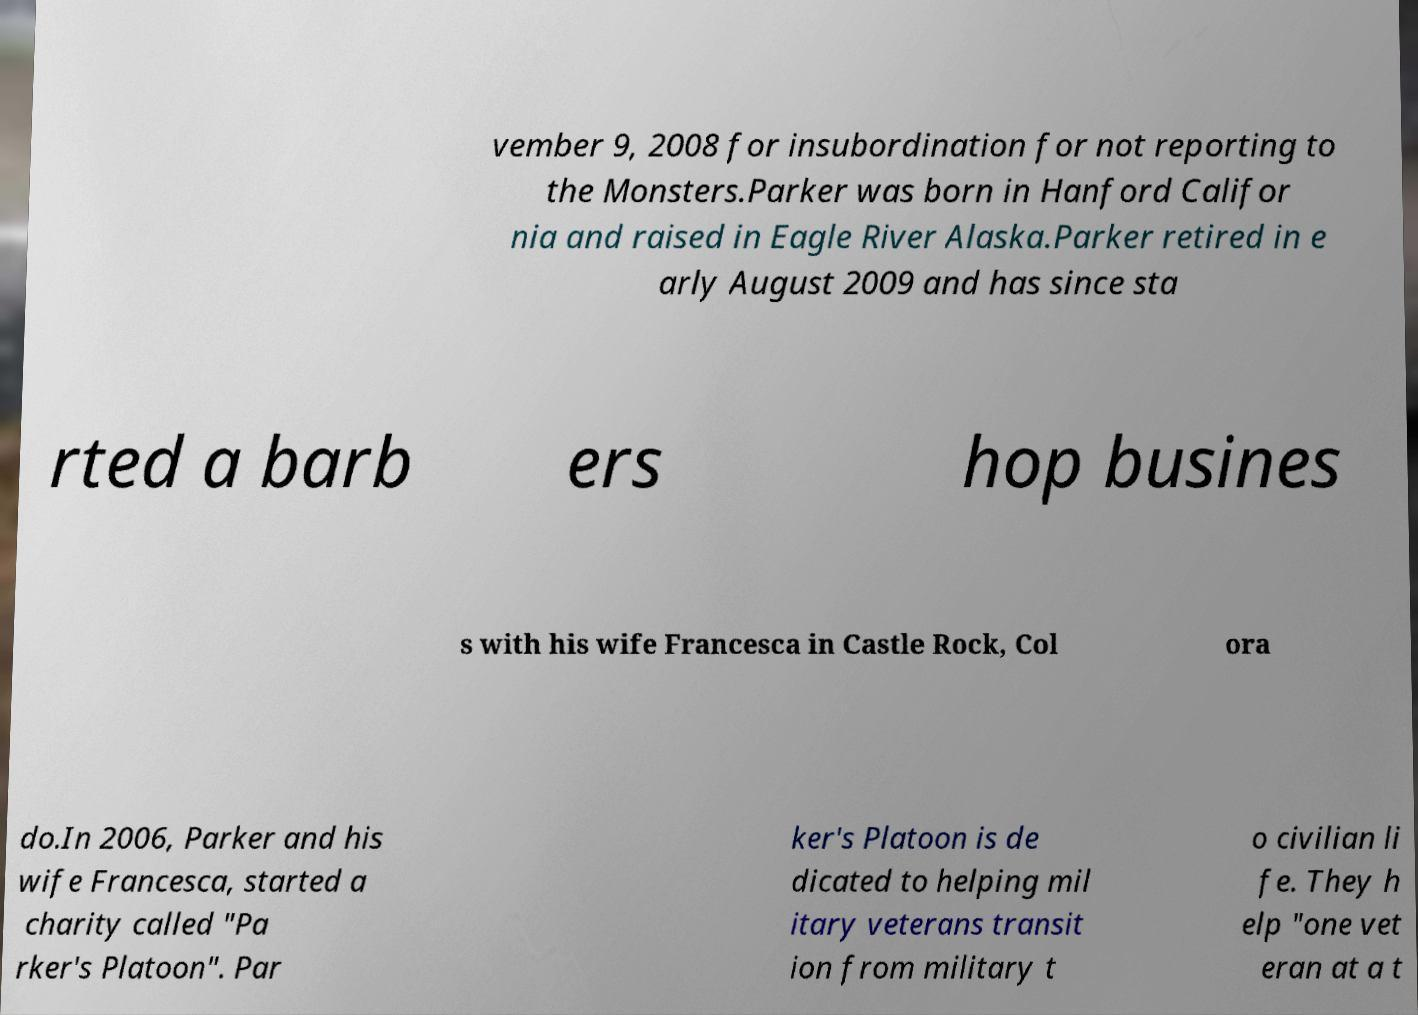Please read and relay the text visible in this image. What does it say? vember 9, 2008 for insubordination for not reporting to the Monsters.Parker was born in Hanford Califor nia and raised in Eagle River Alaska.Parker retired in e arly August 2009 and has since sta rted a barb ers hop busines s with his wife Francesca in Castle Rock, Col ora do.In 2006, Parker and his wife Francesca, started a charity called "Pa rker's Platoon". Par ker's Platoon is de dicated to helping mil itary veterans transit ion from military t o civilian li fe. They h elp "one vet eran at a t 